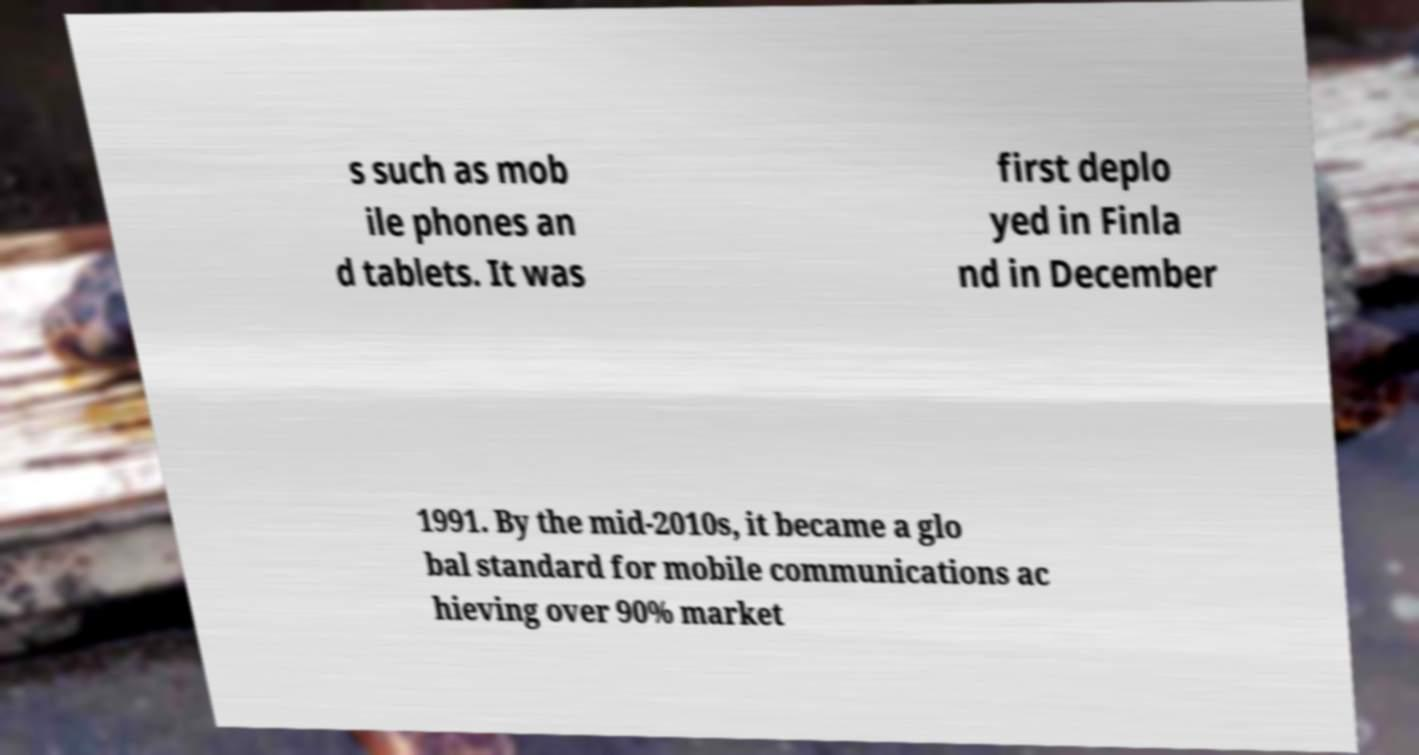What messages or text are displayed in this image? I need them in a readable, typed format. s such as mob ile phones an d tablets. It was first deplo yed in Finla nd in December 1991. By the mid-2010s, it became a glo bal standard for mobile communications ac hieving over 90% market 